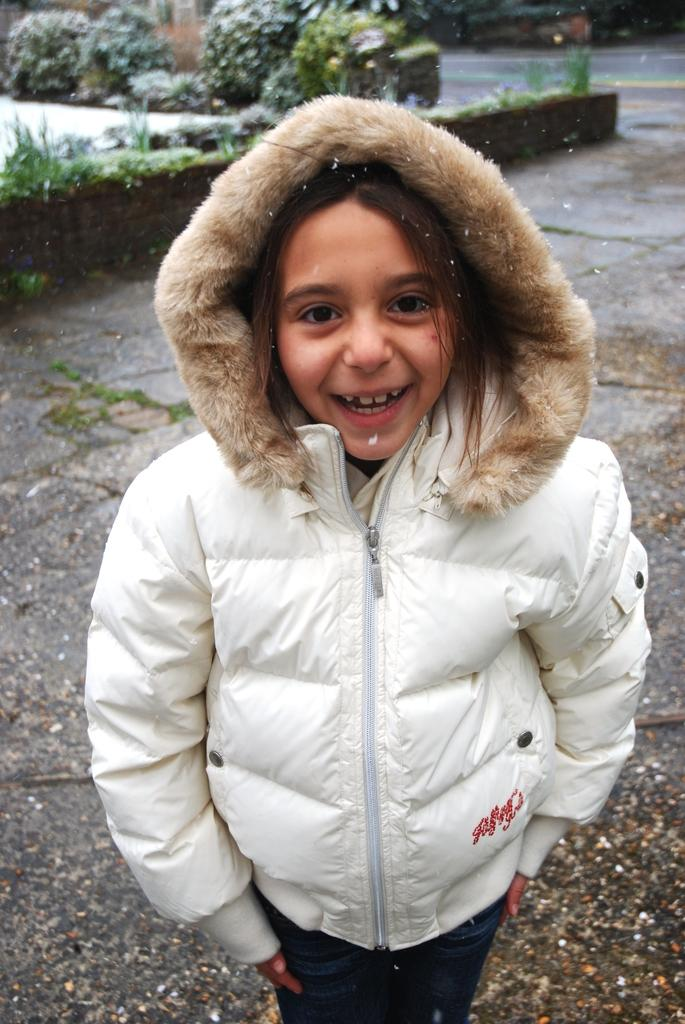Who is the main subject in the image? There is a girl in the image. What is the girl wearing? The girl is wearing a white jacket. What is the girl doing in the image? The girl is standing, smiling, and giving a pose for the picture. What can be seen in the background of the image? There are plants in the background of the image. Where are the plants located in relation to the girl? The plants are on the ground in the background. What nerve does the girl show in the image? The image does not show any specific nerve being displayed by the girl. 